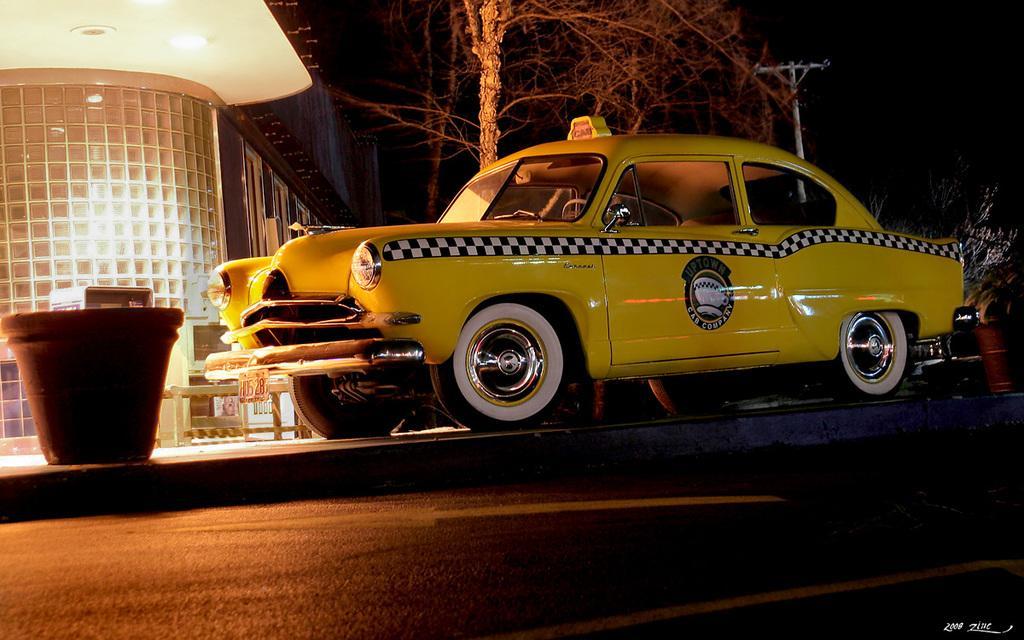Please provide a concise description of this image. In this image, I can see a car and flower pots on the pathway. There is a building, trees and a pole. On the right side of the image, there are plants. At the bottom of the image, I can see a road and the watermark. The background is dark. 